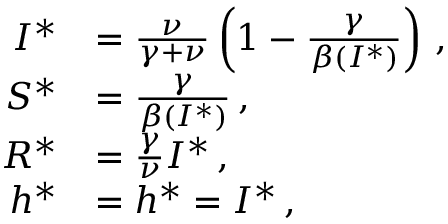Convert formula to latex. <formula><loc_0><loc_0><loc_500><loc_500>\begin{array} { r l } { I ^ { * } } & { = \frac { \nu } { \gamma + \nu } \left ( 1 - \frac { \gamma } { \beta ( I ^ { * } ) } \right ) \, , } \\ { S ^ { * } } & { = \frac { \gamma } { \beta ( I ^ { * } ) } \, , } \\ { R ^ { * } } & { = \frac { \gamma } { \nu } I ^ { * } \, , } \\ { h ^ { * } } & { = h ^ { * } = I ^ { * } \, , } \end{array}</formula> 